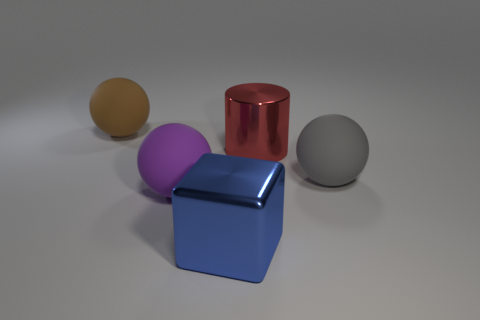There is a large thing in front of the purple rubber ball; what material is it?
Provide a succinct answer. Metal. How many other objects are the same size as the blue metallic cube?
Your response must be concise. 4. Is the size of the metallic cylinder the same as the rubber thing behind the gray matte thing?
Keep it short and to the point. Yes. The rubber object right of the ball that is in front of the large ball that is on the right side of the red cylinder is what shape?
Ensure brevity in your answer.  Sphere. Are there fewer matte things than shiny cylinders?
Offer a terse response. No. Are there any large shiny blocks in front of the gray sphere?
Make the answer very short. Yes. There is a large matte thing that is left of the red shiny object and in front of the brown object; what shape is it?
Your answer should be compact. Sphere. Is there a large rubber object that has the same shape as the blue metal thing?
Give a very brief answer. No. Is the size of the metal block in front of the big purple matte object the same as the matte thing that is on the right side of the large purple ball?
Ensure brevity in your answer.  Yes. Is the number of large red metallic cylinders greater than the number of large rubber balls?
Provide a short and direct response. No. 